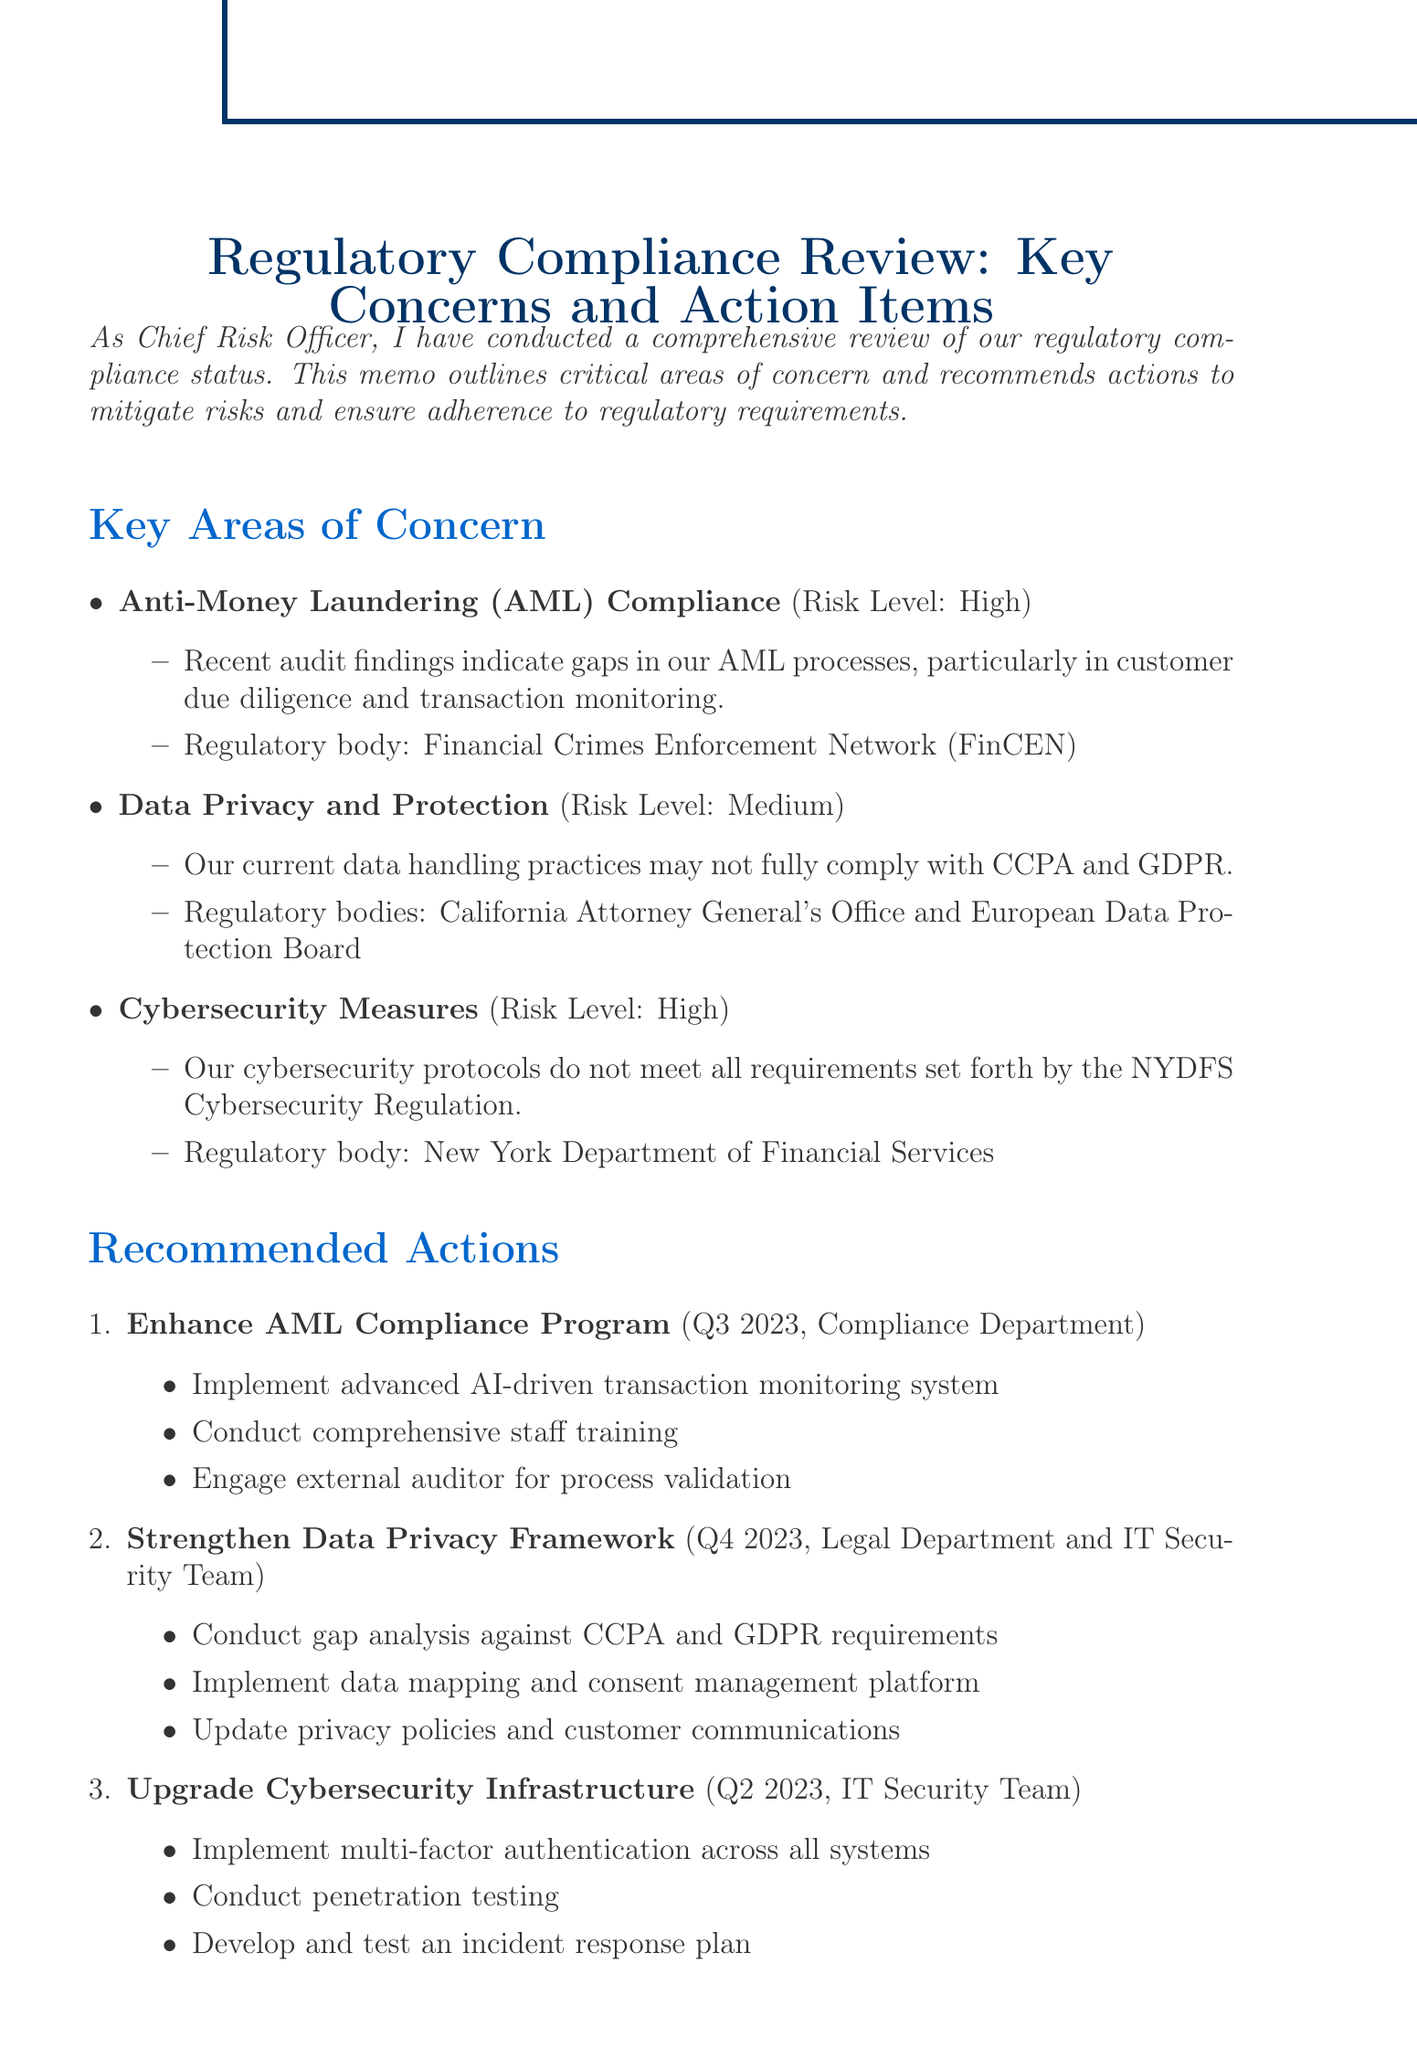What is the title of the memo? The title of the memo is presented at the beginning of the document, which is Regulatory Compliance Review: Key Concerns and Action Items.
Answer: Regulatory Compliance Review: Key Concerns and Action Items What is the risk level for Anti-Money Laundering compliance? The risk level is classified in the key areas of concern section, specifically indicating that it is High.
Answer: High Which regulatory body oversees Data Privacy and Protection? The regulatory body is mentioned in the context of the data privacy area of concern and refers to California Attorney General's Office and European Data Protection Board.
Answer: California Attorney General's Office and European Data Protection Board What is the estimated cost for upgrading cybersecurity infrastructure? The estimated cost for this action item is listed in the financial implications section as $3.2 million.
Answer: $3.2 million Which department is responsible for enhancing the AML Compliance Program? The responsible party is specified for each recommended action, identifying that the Compliance Department is in charge of the AML Compliance Program.
Answer: Compliance Department How many steps are recommended to enhance the AML Compliance Program? The document details the steps to take in the recommended actions section, indicating there are three steps to enhance the AML Compliance Program.
Answer: Three What is the potential fine for AML non-compliance? Potential fines are listed under financial implications, showing that the fine could be up to $25 million.
Answer: Up to $25 million When is the timeline for strengthening the Data Privacy Framework? The timeline can be found under the recommended actions, indicating that it is set for Q4 2023.
Answer: Q4 2023 